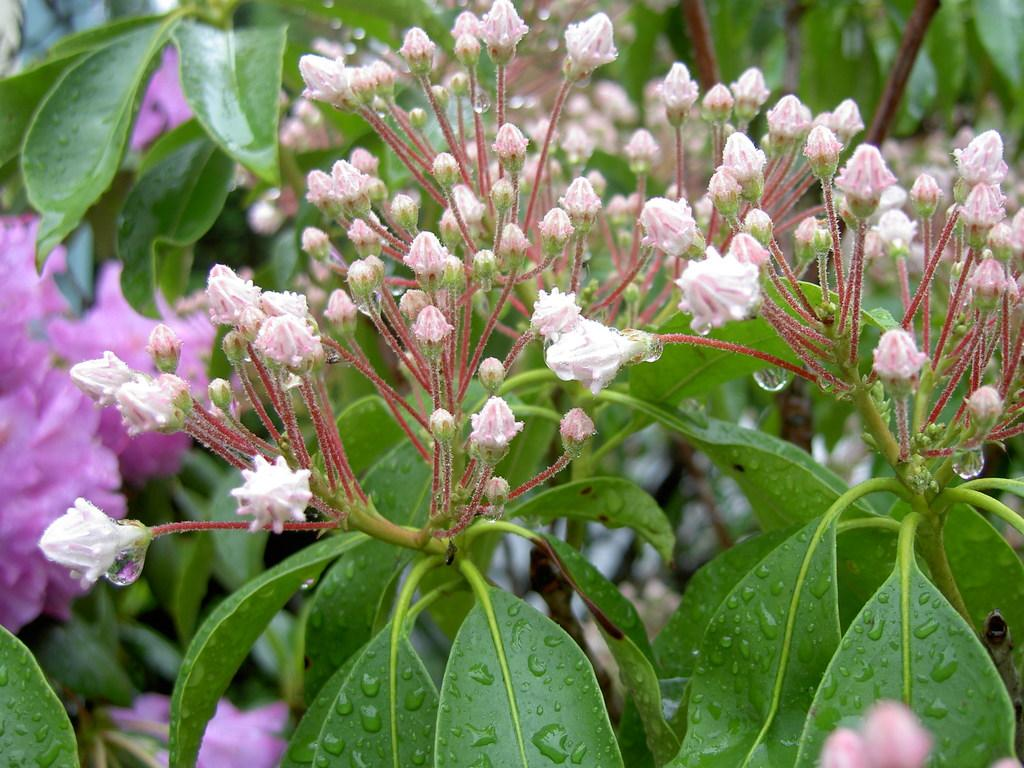What type of plants can be seen in the image? There are flowers in the image. What other parts of the plants are visible in the image? There are leaves and flower buds visible in the image. How many bikes are parked next to the flowers in the image? There are no bikes present in the image. Can you tell me how many copies of the flowers are in the image? There is only one set of flowers visible in the image, not multiple copies. 